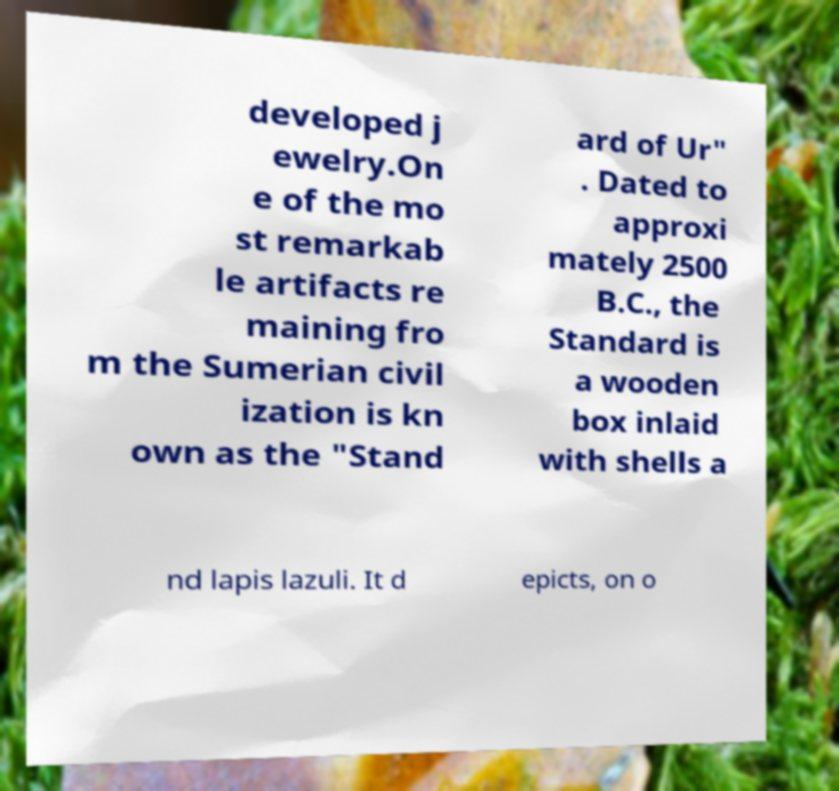Could you assist in decoding the text presented in this image and type it out clearly? developed j ewelry.On e of the mo st remarkab le artifacts re maining fro m the Sumerian civil ization is kn own as the "Stand ard of Ur" . Dated to approxi mately 2500 B.C., the Standard is a wooden box inlaid with shells a nd lapis lazuli. It d epicts, on o 